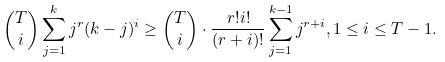<formula> <loc_0><loc_0><loc_500><loc_500>\binom { T } { i } \sum ^ { k } _ { j = 1 } j ^ { r } ( k - j ) ^ { i } \geq \binom { T } { i } \cdot \frac { r ! i ! } { ( r + i ) ! } \sum ^ { k - 1 } _ { j = 1 } j ^ { r + i } , 1 \leq i \leq T - 1 .</formula> 